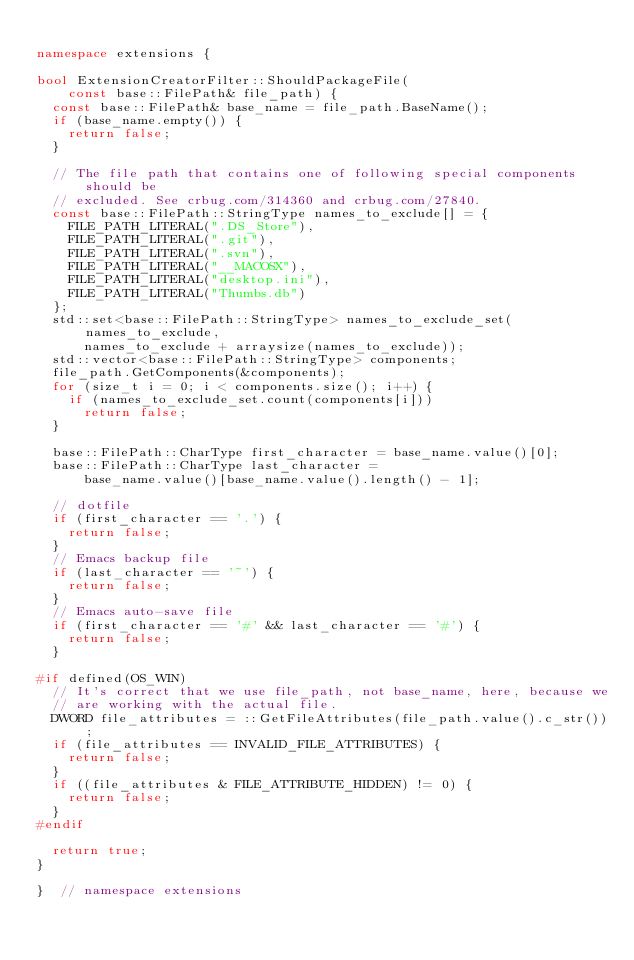<code> <loc_0><loc_0><loc_500><loc_500><_C++_>
namespace extensions {

bool ExtensionCreatorFilter::ShouldPackageFile(
    const base::FilePath& file_path) {
  const base::FilePath& base_name = file_path.BaseName();
  if (base_name.empty()) {
    return false;
  }

  // The file path that contains one of following special components should be
  // excluded. See crbug.com/314360 and crbug.com/27840.
  const base::FilePath::StringType names_to_exclude[] = {
    FILE_PATH_LITERAL(".DS_Store"),
    FILE_PATH_LITERAL(".git"),
    FILE_PATH_LITERAL(".svn"),
    FILE_PATH_LITERAL("__MACOSX"),
    FILE_PATH_LITERAL("desktop.ini"),
    FILE_PATH_LITERAL("Thumbs.db")
  };
  std::set<base::FilePath::StringType> names_to_exclude_set(names_to_exclude,
      names_to_exclude + arraysize(names_to_exclude));
  std::vector<base::FilePath::StringType> components;
  file_path.GetComponents(&components);
  for (size_t i = 0; i < components.size(); i++) {
    if (names_to_exclude_set.count(components[i]))
      return false;
  }

  base::FilePath::CharType first_character = base_name.value()[0];
  base::FilePath::CharType last_character =
      base_name.value()[base_name.value().length() - 1];

  // dotfile
  if (first_character == '.') {
    return false;
  }
  // Emacs backup file
  if (last_character == '~') {
    return false;
  }
  // Emacs auto-save file
  if (first_character == '#' && last_character == '#') {
    return false;
  }

#if defined(OS_WIN)
  // It's correct that we use file_path, not base_name, here, because we
  // are working with the actual file.
  DWORD file_attributes = ::GetFileAttributes(file_path.value().c_str());
  if (file_attributes == INVALID_FILE_ATTRIBUTES) {
    return false;
  }
  if ((file_attributes & FILE_ATTRIBUTE_HIDDEN) != 0) {
    return false;
  }
#endif

  return true;
}

}  // namespace extensions
</code> 